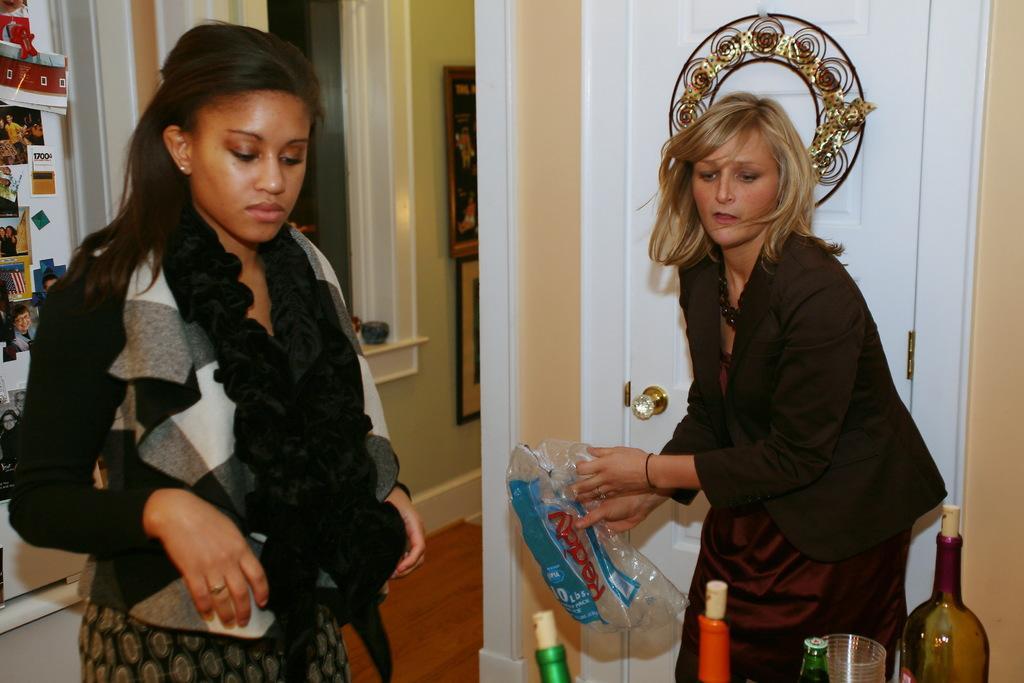How would you summarize this image in a sentence or two? In this image there are two women standing in the room. At the back side we can see a wall and frames attached to the wall. There is a bottle and a glass. 